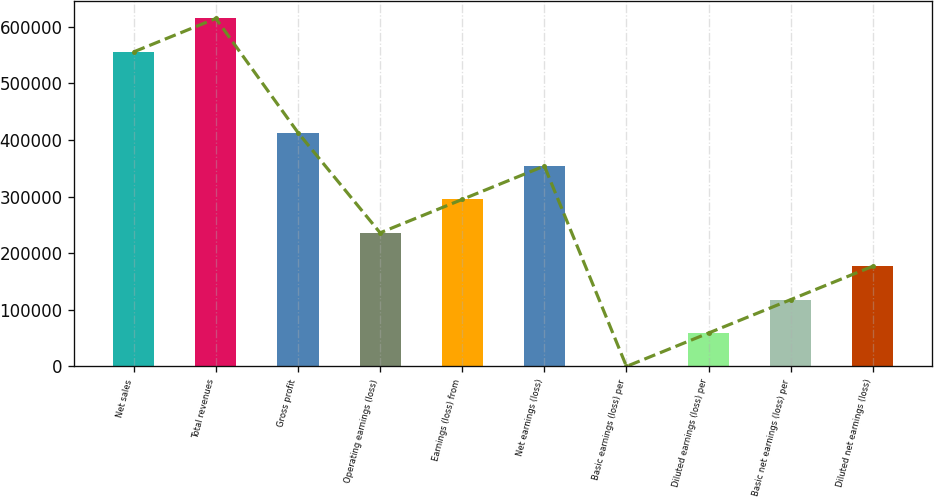Convert chart to OTSL. <chart><loc_0><loc_0><loc_500><loc_500><bar_chart><fcel>Net sales<fcel>Total revenues<fcel>Gross profit<fcel>Operating earnings (loss)<fcel>Earnings (loss) from<fcel>Net earnings (loss)<fcel>Basic earnings (loss) per<fcel>Diluted earnings (loss) per<fcel>Basic net earnings (loss) per<fcel>Diluted net earnings (loss)<nl><fcel>555768<fcel>614782<fcel>413102<fcel>236058<fcel>295073<fcel>354087<fcel>0.1<fcel>59014.6<fcel>118029<fcel>177044<nl></chart> 